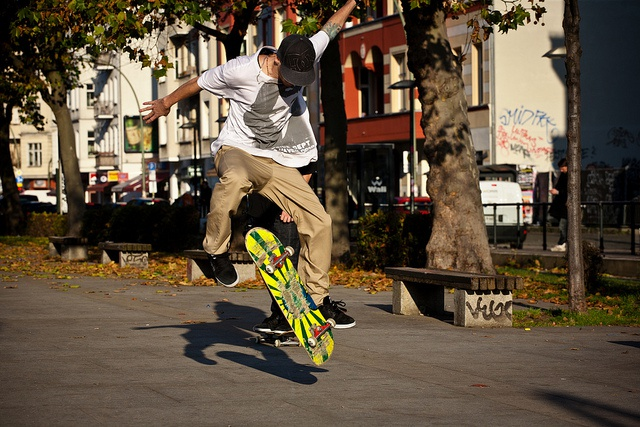Describe the objects in this image and their specific colors. I can see people in black, lightgray, tan, and gray tones, bench in black, maroon, and tan tones, skateboard in black, yellow, tan, and gray tones, car in black, ivory, beige, and gray tones, and truck in black, ivory, lightgray, and darkgray tones in this image. 